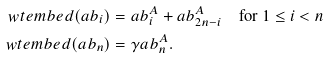Convert formula to latex. <formula><loc_0><loc_0><loc_500><loc_500>\ w t e m b e d ( \L a b _ { i } ) & = \L a b _ { i } ^ { A } + \L a b _ { 2 n - i } ^ { A } \quad \text {for $1\leq i<n$} \\ \ w t e m b e d ( \L a b _ { n } ) & = \gamma \L a b _ { n } ^ { A } .</formula> 